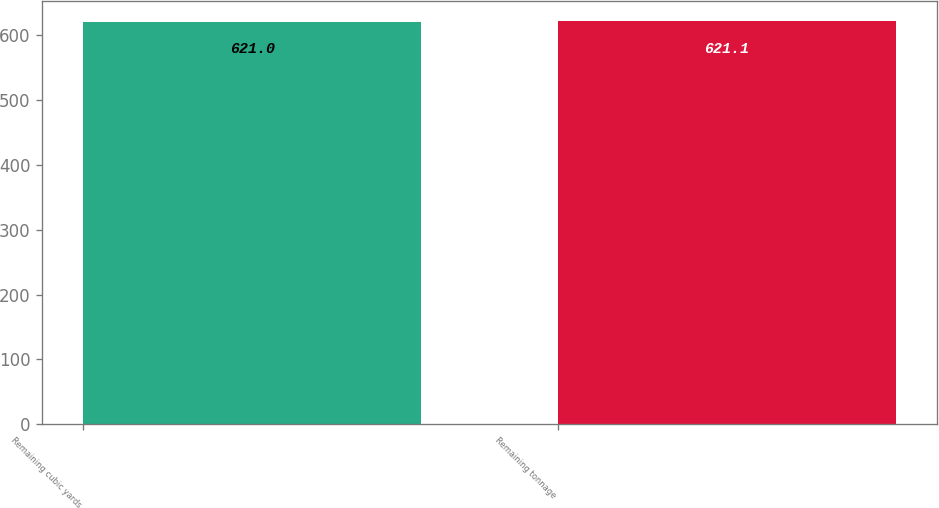Convert chart. <chart><loc_0><loc_0><loc_500><loc_500><bar_chart><fcel>Remaining cubic yards<fcel>Remaining tonnage<nl><fcel>621<fcel>621.1<nl></chart> 